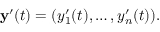Convert formula to latex. <formula><loc_0><loc_0><loc_500><loc_500>y ^ { \prime } ( t ) = ( y _ { 1 } ^ { \prime } ( t ) , \dots , y _ { n } ^ { \prime } ( t ) ) .</formula> 